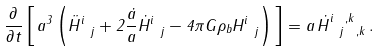Convert formula to latex. <formula><loc_0><loc_0><loc_500><loc_500>\frac { \partial } { \partial t } \left [ \, a ^ { 3 } \left ( \ddot { H } ^ { i } _ { \ j } + 2 \frac { \dot { a } } { a } \dot { H } ^ { i } _ { \ j } - 4 \pi G \rho _ { b } H ^ { i } _ { \ j } \right ) \, \right ] = a \, \dot { H } ^ { i \ , k } _ { \ j \ , k } \, .</formula> 